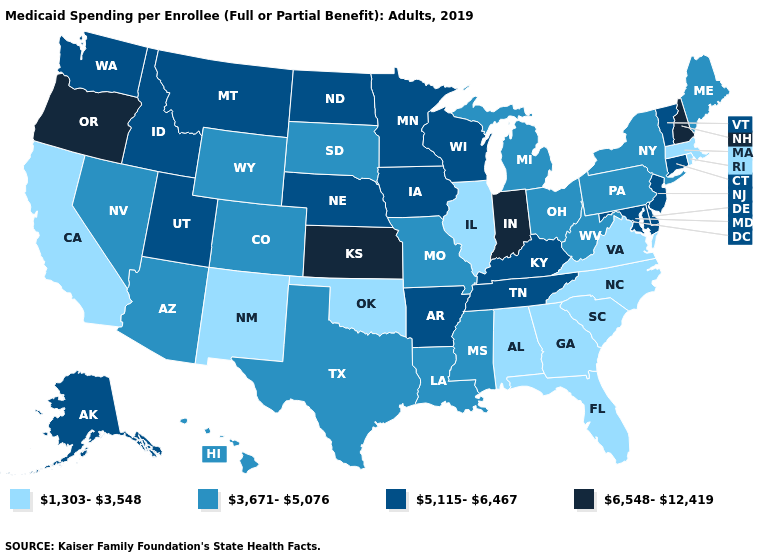What is the highest value in the USA?
Write a very short answer. 6,548-12,419. Is the legend a continuous bar?
Be succinct. No. Does Oregon have the highest value in the USA?
Keep it brief. Yes. What is the highest value in the West ?
Short answer required. 6,548-12,419. What is the value of Florida?
Quick response, please. 1,303-3,548. Does New Mexico have a lower value than Nebraska?
Keep it brief. Yes. What is the lowest value in states that border Virginia?
Quick response, please. 1,303-3,548. What is the highest value in states that border New York?
Give a very brief answer. 5,115-6,467. Which states have the highest value in the USA?
Write a very short answer. Indiana, Kansas, New Hampshire, Oregon. Name the states that have a value in the range 3,671-5,076?
Write a very short answer. Arizona, Colorado, Hawaii, Louisiana, Maine, Michigan, Mississippi, Missouri, Nevada, New York, Ohio, Pennsylvania, South Dakota, Texas, West Virginia, Wyoming. Which states have the highest value in the USA?
Quick response, please. Indiana, Kansas, New Hampshire, Oregon. What is the value of Alaska?
Keep it brief. 5,115-6,467. Name the states that have a value in the range 6,548-12,419?
Keep it brief. Indiana, Kansas, New Hampshire, Oregon. Does Oregon have the highest value in the West?
Quick response, please. Yes. What is the value of Missouri?
Write a very short answer. 3,671-5,076. 